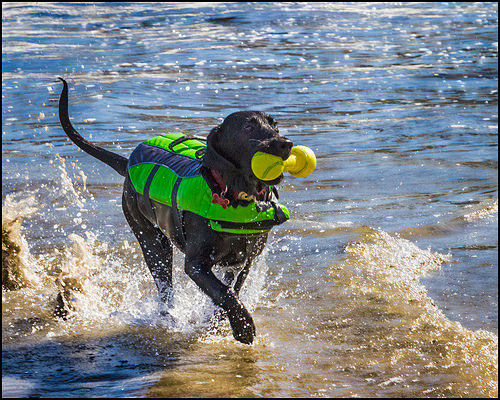<image>
Is there a dog on the water? Yes. Looking at the image, I can see the dog is positioned on top of the water, with the water providing support. 